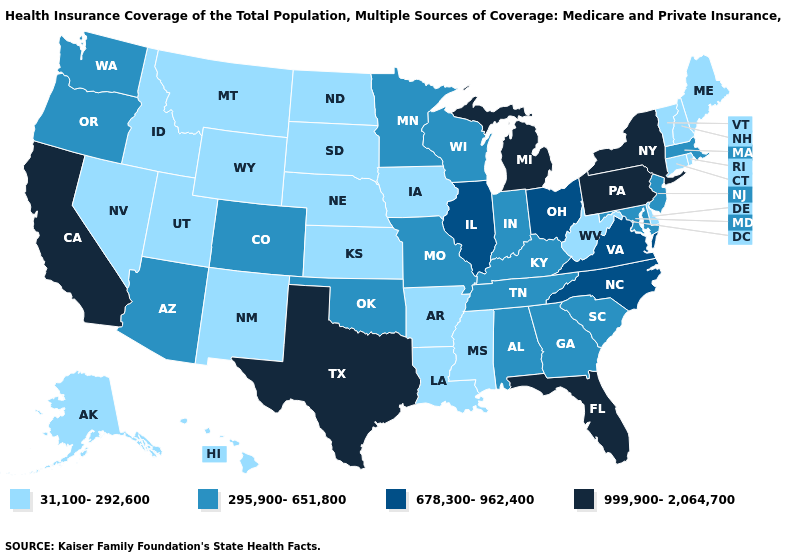What is the lowest value in the USA?
Short answer required. 31,100-292,600. What is the lowest value in states that border Washington?
Concise answer only. 31,100-292,600. Which states hav the highest value in the West?
Keep it brief. California. Among the states that border California , does Arizona have the highest value?
Write a very short answer. Yes. What is the highest value in states that border Nebraska?
Write a very short answer. 295,900-651,800. What is the value of Kentucky?
Short answer required. 295,900-651,800. How many symbols are there in the legend?
Answer briefly. 4. What is the value of Mississippi?
Answer briefly. 31,100-292,600. What is the value of Pennsylvania?
Write a very short answer. 999,900-2,064,700. What is the lowest value in the South?
Be succinct. 31,100-292,600. Does New York have the lowest value in the Northeast?
Short answer required. No. Among the states that border Idaho , which have the highest value?
Answer briefly. Oregon, Washington. Does Vermont have a lower value than Utah?
Answer briefly. No. Name the states that have a value in the range 31,100-292,600?
Write a very short answer. Alaska, Arkansas, Connecticut, Delaware, Hawaii, Idaho, Iowa, Kansas, Louisiana, Maine, Mississippi, Montana, Nebraska, Nevada, New Hampshire, New Mexico, North Dakota, Rhode Island, South Dakota, Utah, Vermont, West Virginia, Wyoming. Name the states that have a value in the range 31,100-292,600?
Write a very short answer. Alaska, Arkansas, Connecticut, Delaware, Hawaii, Idaho, Iowa, Kansas, Louisiana, Maine, Mississippi, Montana, Nebraska, Nevada, New Hampshire, New Mexico, North Dakota, Rhode Island, South Dakota, Utah, Vermont, West Virginia, Wyoming. 